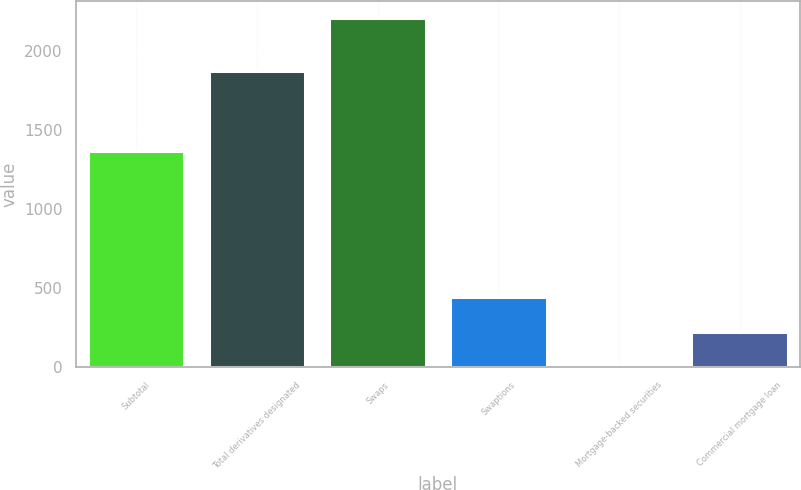Convert chart to OTSL. <chart><loc_0><loc_0><loc_500><loc_500><bar_chart><fcel>Subtotal<fcel>Total derivatives designated<fcel>Swaps<fcel>Swaptions<fcel>Mortgage-backed securities<fcel>Commercial mortgage loan<nl><fcel>1367<fcel>1872<fcel>2204<fcel>443.2<fcel>3<fcel>223.1<nl></chart> 